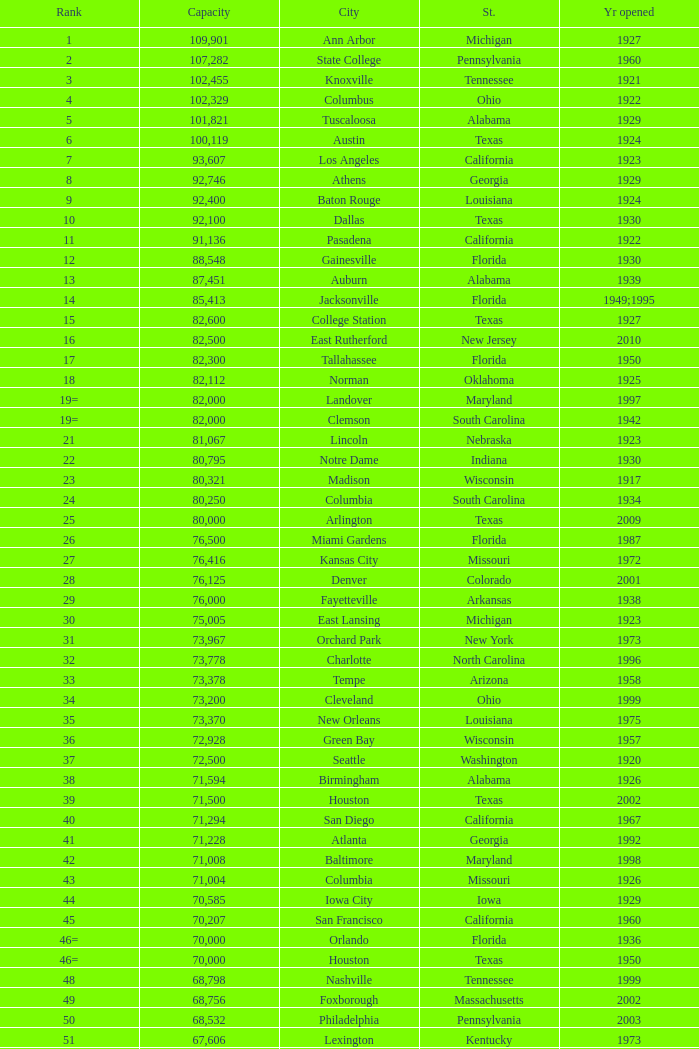What was the year opened for North Carolina with a smaller than 21,500 capacity? 1926.0. 